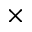<formula> <loc_0><loc_0><loc_500><loc_500>\times</formula> 